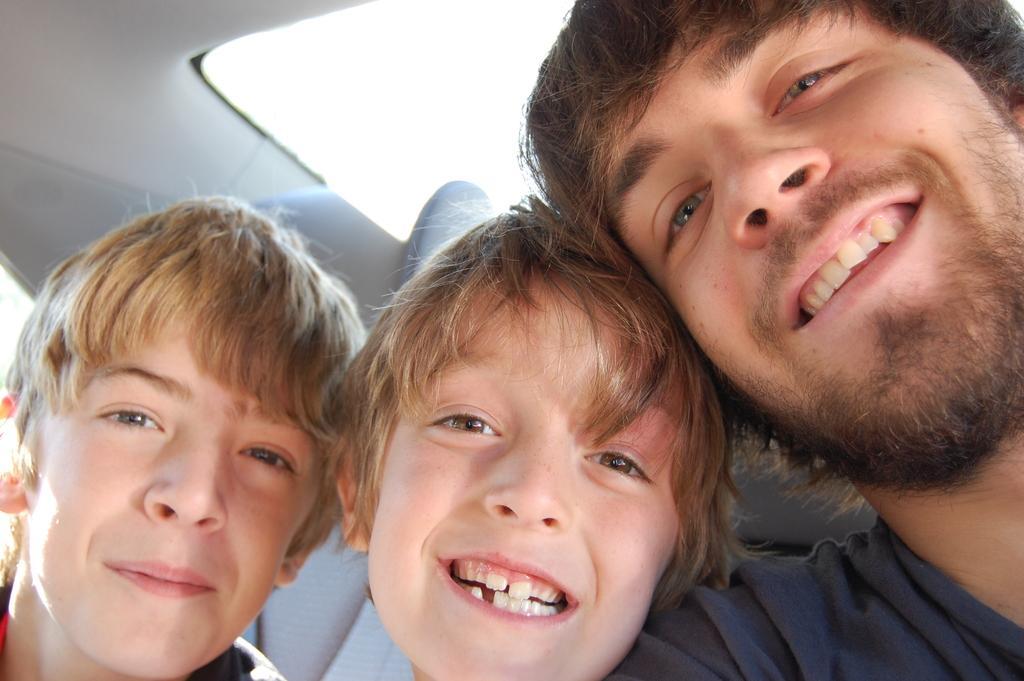Please provide a concise description of this image. In this picture we can observe three members. All of them are smiling. One of them is a man and the other two are boys. They are sitting in a vehicle. In the background we can observe back windshield of a vehicle. 